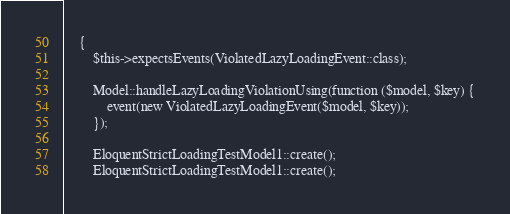Convert code to text. <code><loc_0><loc_0><loc_500><loc_500><_PHP_>    {
        $this->expectsEvents(ViolatedLazyLoadingEvent::class);

        Model::handleLazyLoadingViolationUsing(function ($model, $key) {
            event(new ViolatedLazyLoadingEvent($model, $key));
        });

        EloquentStrictLoadingTestModel1::create();
        EloquentStrictLoadingTestModel1::create();
</code> 